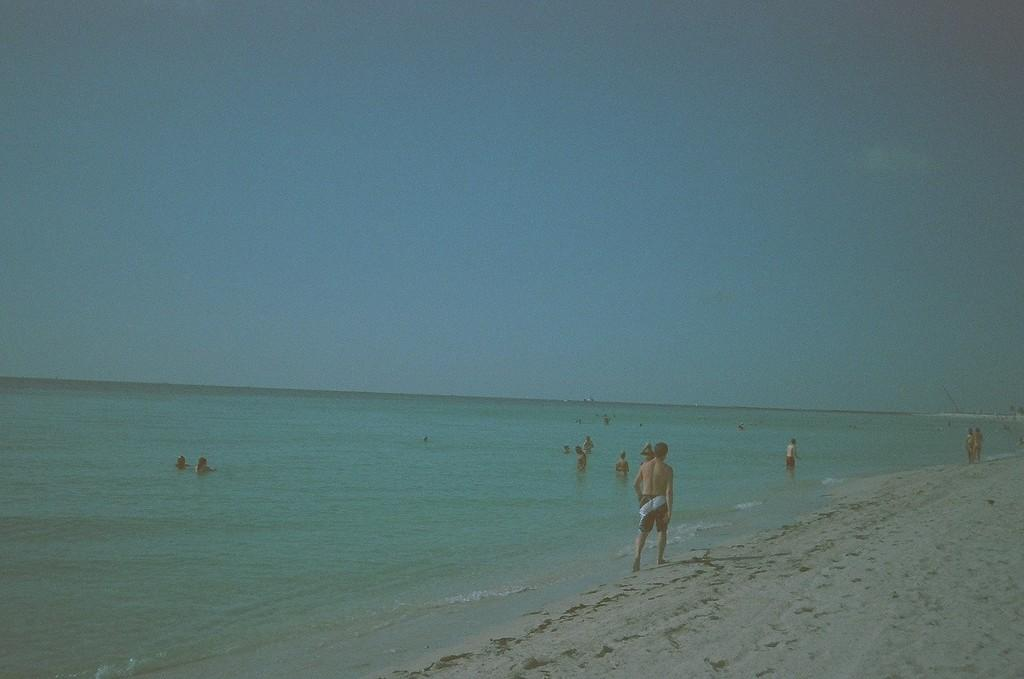Who or what is present in the image? There are people in the image. What can be seen at the top of the image? The sky is visible at the top of the image. What is located at the bottom of the image? There is water and sand at the bottom of the image. How many tickets are visible in the image? There are no tickets present in the image. What type of good-bye is being said in the image? There is no indication of anyone saying good-bye in the image. 